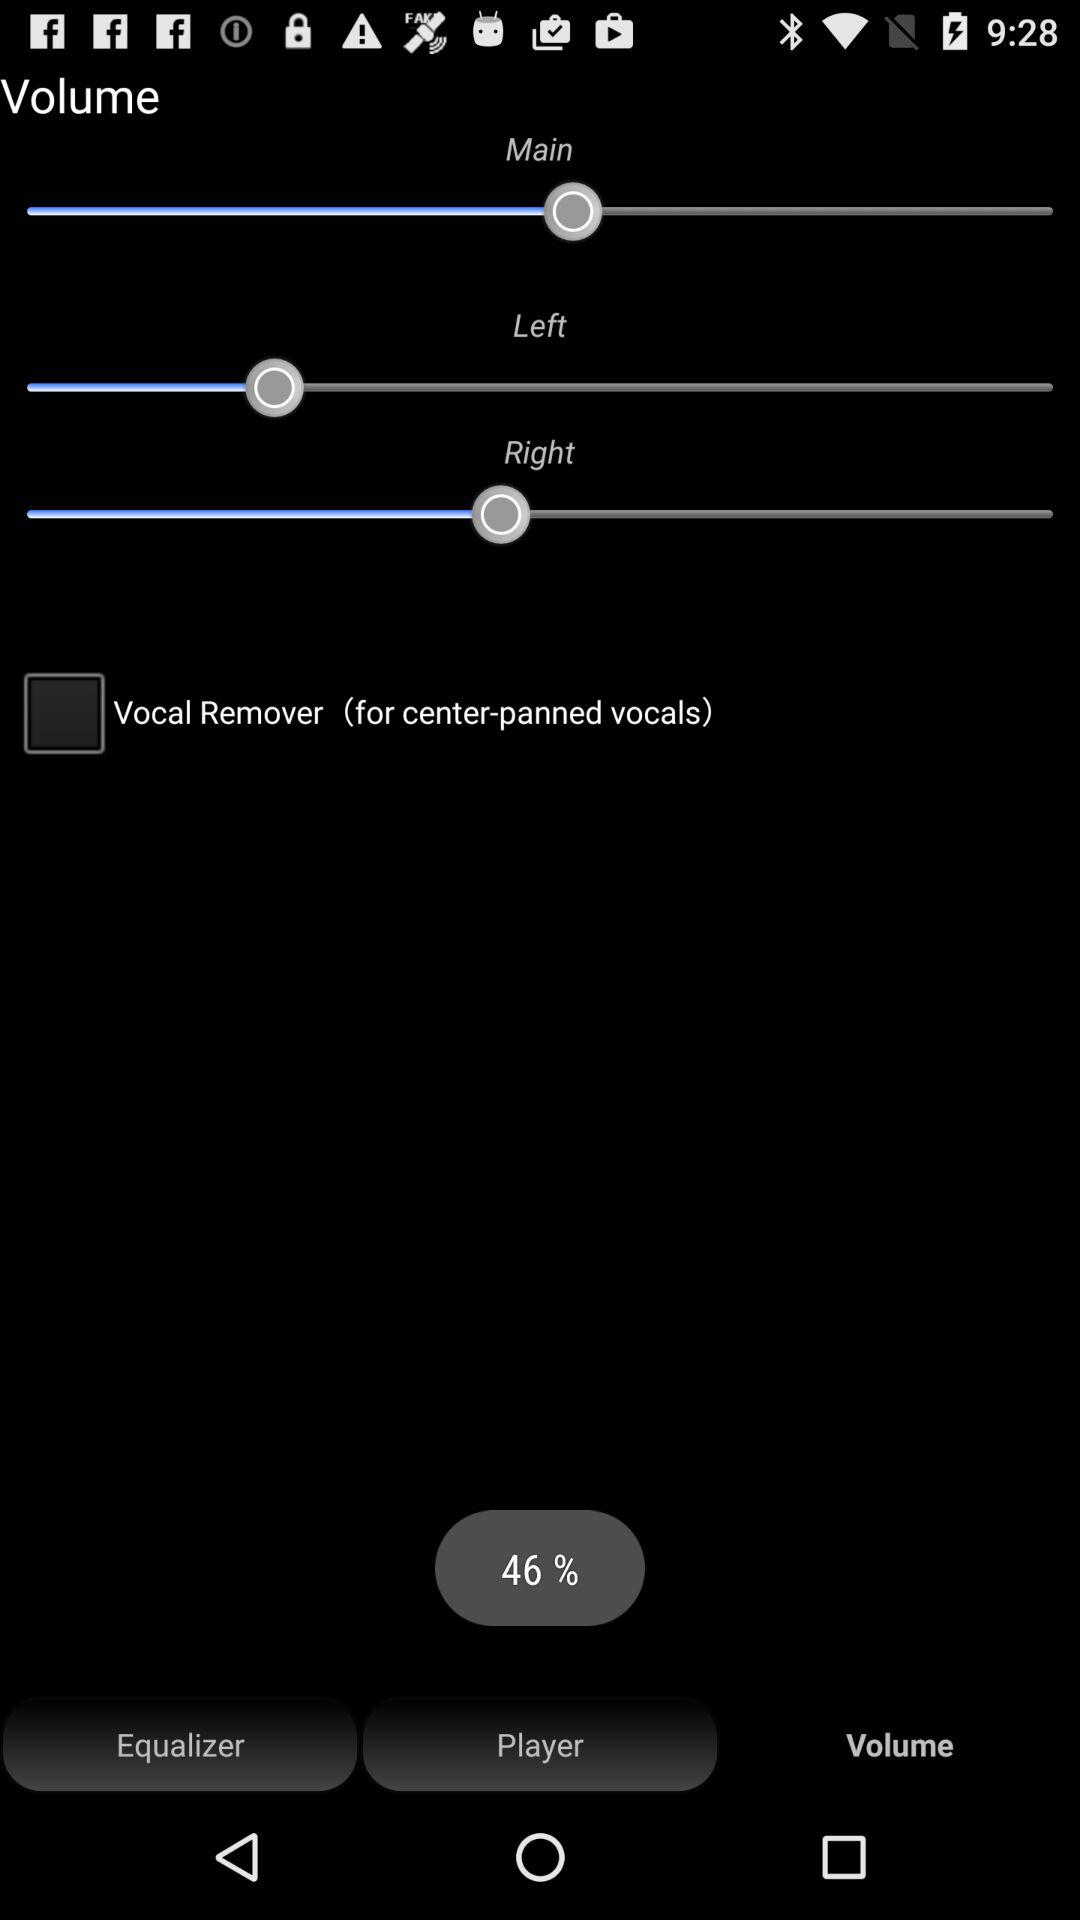How much is the loading?
When the provided information is insufficient, respond with <no answer>. <no answer> 